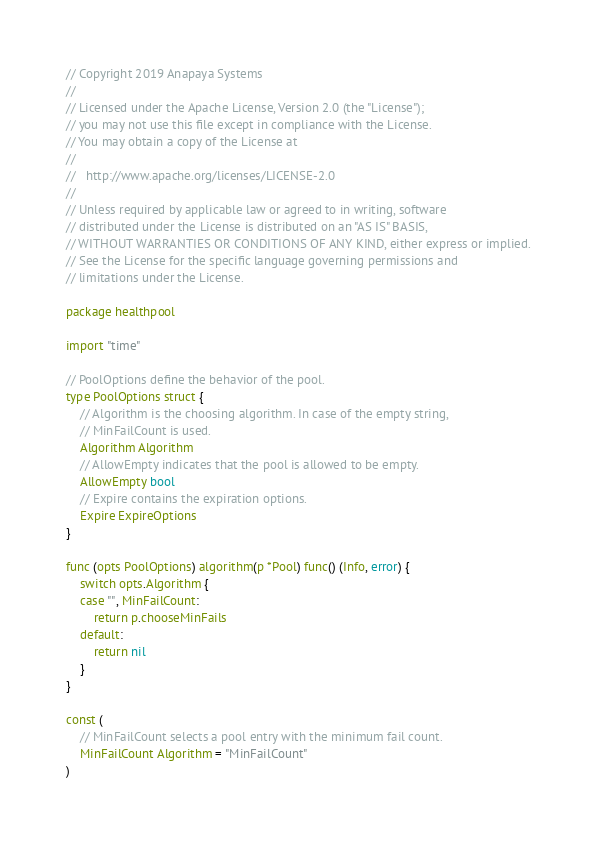<code> <loc_0><loc_0><loc_500><loc_500><_Go_>// Copyright 2019 Anapaya Systems
//
// Licensed under the Apache License, Version 2.0 (the "License");
// you may not use this file except in compliance with the License.
// You may obtain a copy of the License at
//
//   http://www.apache.org/licenses/LICENSE-2.0
//
// Unless required by applicable law or agreed to in writing, software
// distributed under the License is distributed on an "AS IS" BASIS,
// WITHOUT WARRANTIES OR CONDITIONS OF ANY KIND, either express or implied.
// See the License for the specific language governing permissions and
// limitations under the License.

package healthpool

import "time"

// PoolOptions define the behavior of the pool.
type PoolOptions struct {
	// Algorithm is the choosing algorithm. In case of the empty string,
	// MinFailCount is used.
	Algorithm Algorithm
	// AllowEmpty indicates that the pool is allowed to be empty.
	AllowEmpty bool
	// Expire contains the expiration options.
	Expire ExpireOptions
}

func (opts PoolOptions) algorithm(p *Pool) func() (Info, error) {
	switch opts.Algorithm {
	case "", MinFailCount:
		return p.chooseMinFails
	default:
		return nil
	}
}

const (
	// MinFailCount selects a pool entry with the minimum fail count.
	MinFailCount Algorithm = "MinFailCount"
)
</code> 